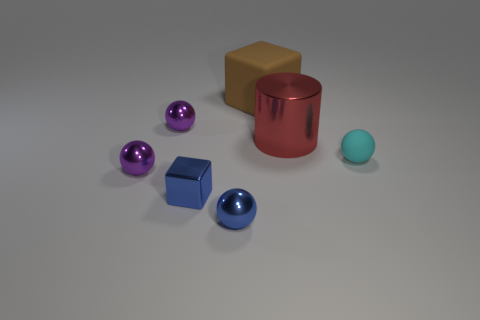What number of other things are the same shape as the large red metal thing?
Give a very brief answer. 0. Is the number of balls to the left of the red thing greater than the number of cyan matte objects in front of the tiny metallic block?
Your answer should be very brief. Yes. There is a matte object that is on the right side of the big red object; is it the same size as the block to the left of the blue metal sphere?
Offer a terse response. Yes. The small cyan object is what shape?
Your response must be concise. Sphere. The ball that is the same color as the small shiny block is what size?
Provide a succinct answer. Small. What color is the block that is the same material as the large red object?
Provide a succinct answer. Blue. Is the tiny cyan thing made of the same material as the small purple sphere that is in front of the cylinder?
Make the answer very short. No. What is the color of the large matte object?
Your answer should be very brief. Brown. The cyan thing that is made of the same material as the big brown thing is what size?
Give a very brief answer. Small. There is a purple ball to the right of the tiny purple metal ball in front of the tiny matte ball; how many shiny spheres are in front of it?
Provide a succinct answer. 2. 